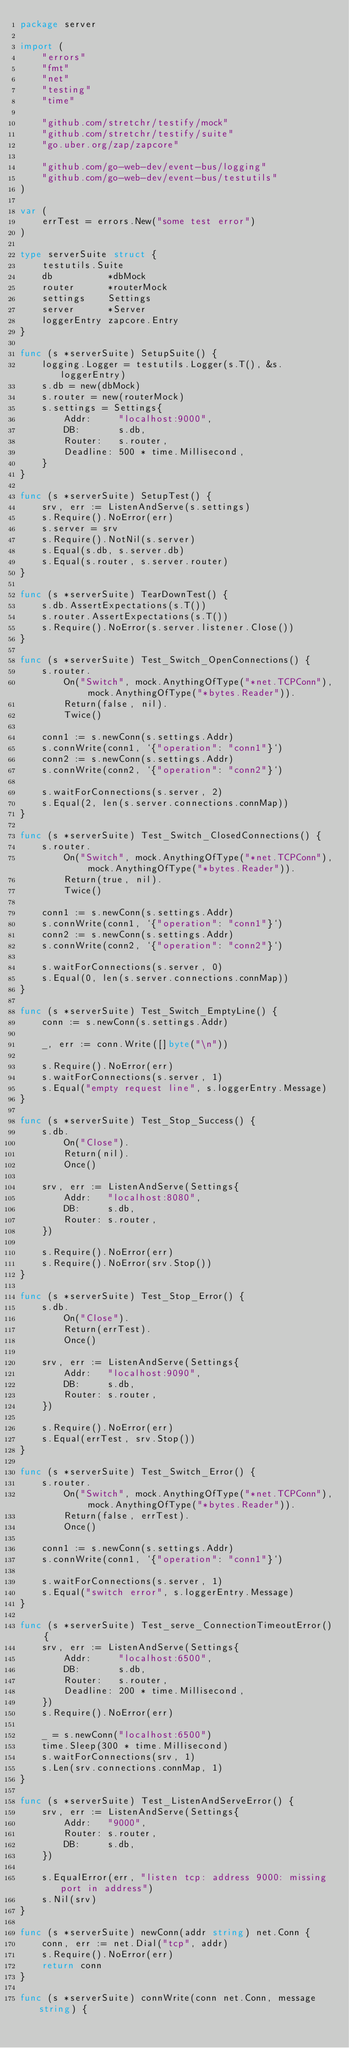<code> <loc_0><loc_0><loc_500><loc_500><_Go_>package server

import (
	"errors"
	"fmt"
	"net"
	"testing"
	"time"

	"github.com/stretchr/testify/mock"
	"github.com/stretchr/testify/suite"
	"go.uber.org/zap/zapcore"

	"github.com/go-web-dev/event-bus/logging"
	"github.com/go-web-dev/event-bus/testutils"
)

var (
	errTest = errors.New("some test error")
)

type serverSuite struct {
	testutils.Suite
	db          *dbMock
	router      *routerMock
	settings    Settings
	server      *Server
	loggerEntry zapcore.Entry
}

func (s *serverSuite) SetupSuite() {
	logging.Logger = testutils.Logger(s.T(), &s.loggerEntry)
	s.db = new(dbMock)
	s.router = new(routerMock)
	s.settings = Settings{
		Addr:     "localhost:9000",
		DB:       s.db,
		Router:   s.router,
		Deadline: 500 * time.Millisecond,
	}
}

func (s *serverSuite) SetupTest() {
	srv, err := ListenAndServe(s.settings)
	s.Require().NoError(err)
	s.server = srv
	s.Require().NotNil(s.server)
	s.Equal(s.db, s.server.db)
	s.Equal(s.router, s.server.router)
}

func (s *serverSuite) TearDownTest() {
	s.db.AssertExpectations(s.T())
	s.router.AssertExpectations(s.T())
	s.Require().NoError(s.server.listener.Close())
}

func (s *serverSuite) Test_Switch_OpenConnections() {
	s.router.
		On("Switch", mock.AnythingOfType("*net.TCPConn"), mock.AnythingOfType("*bytes.Reader")).
		Return(false, nil).
		Twice()

	conn1 := s.newConn(s.settings.Addr)
	s.connWrite(conn1, `{"operation": "conn1"}`)
	conn2 := s.newConn(s.settings.Addr)
	s.connWrite(conn2, `{"operation": "conn2"}`)

	s.waitForConnections(s.server, 2)
	s.Equal(2, len(s.server.connections.connMap))
}

func (s *serverSuite) Test_Switch_ClosedConnections() {
	s.router.
		On("Switch", mock.AnythingOfType("*net.TCPConn"), mock.AnythingOfType("*bytes.Reader")).
		Return(true, nil).
		Twice()

	conn1 := s.newConn(s.settings.Addr)
	s.connWrite(conn1, `{"operation": "conn1"}`)
	conn2 := s.newConn(s.settings.Addr)
	s.connWrite(conn2, `{"operation": "conn2"}`)

	s.waitForConnections(s.server, 0)
	s.Equal(0, len(s.server.connections.connMap))
}

func (s *serverSuite) Test_Switch_EmptyLine() {
	conn := s.newConn(s.settings.Addr)

	_, err := conn.Write([]byte("\n"))

	s.Require().NoError(err)
	s.waitForConnections(s.server, 1)
	s.Equal("empty request line", s.loggerEntry.Message)
}

func (s *serverSuite) Test_Stop_Success() {
	s.db.
		On("Close").
		Return(nil).
		Once()

	srv, err := ListenAndServe(Settings{
		Addr:   "localhost:8080",
		DB:     s.db,
		Router: s.router,
	})

	s.Require().NoError(err)
	s.Require().NoError(srv.Stop())
}

func (s *serverSuite) Test_Stop_Error() {
	s.db.
		On("Close").
		Return(errTest).
		Once()

	srv, err := ListenAndServe(Settings{
		Addr:   "localhost:9090",
		DB:     s.db,
		Router: s.router,
	})

	s.Require().NoError(err)
	s.Equal(errTest, srv.Stop())
}

func (s *serverSuite) Test_Switch_Error() {
	s.router.
		On("Switch", mock.AnythingOfType("*net.TCPConn"), mock.AnythingOfType("*bytes.Reader")).
		Return(false, errTest).
		Once()

	conn1 := s.newConn(s.settings.Addr)
	s.connWrite(conn1, `{"operation": "conn1"}`)

	s.waitForConnections(s.server, 1)
	s.Equal("switch error", s.loggerEntry.Message)
}

func (s *serverSuite) Test_serve_ConnectionTimeoutError() {
	srv, err := ListenAndServe(Settings{
		Addr:     "localhost:6500",
		DB:       s.db,
		Router:   s.router,
		Deadline: 200 * time.Millisecond,
	})
	s.Require().NoError(err)

	_ = s.newConn("localhost:6500")
	time.Sleep(300 * time.Millisecond)
	s.waitForConnections(srv, 1)
	s.Len(srv.connections.connMap, 1)
}

func (s *serverSuite) Test_ListenAndServeError() {
	srv, err := ListenAndServe(Settings{
		Addr:   "9000",
		Router: s.router,
		DB:     s.db,
	})

	s.EqualError(err, "listen tcp: address 9000: missing port in address")
	s.Nil(srv)
}

func (s *serverSuite) newConn(addr string) net.Conn {
	conn, err := net.Dial("tcp", addr)
	s.Require().NoError(err)
	return conn
}

func (s *serverSuite) connWrite(conn net.Conn, message string) {</code> 